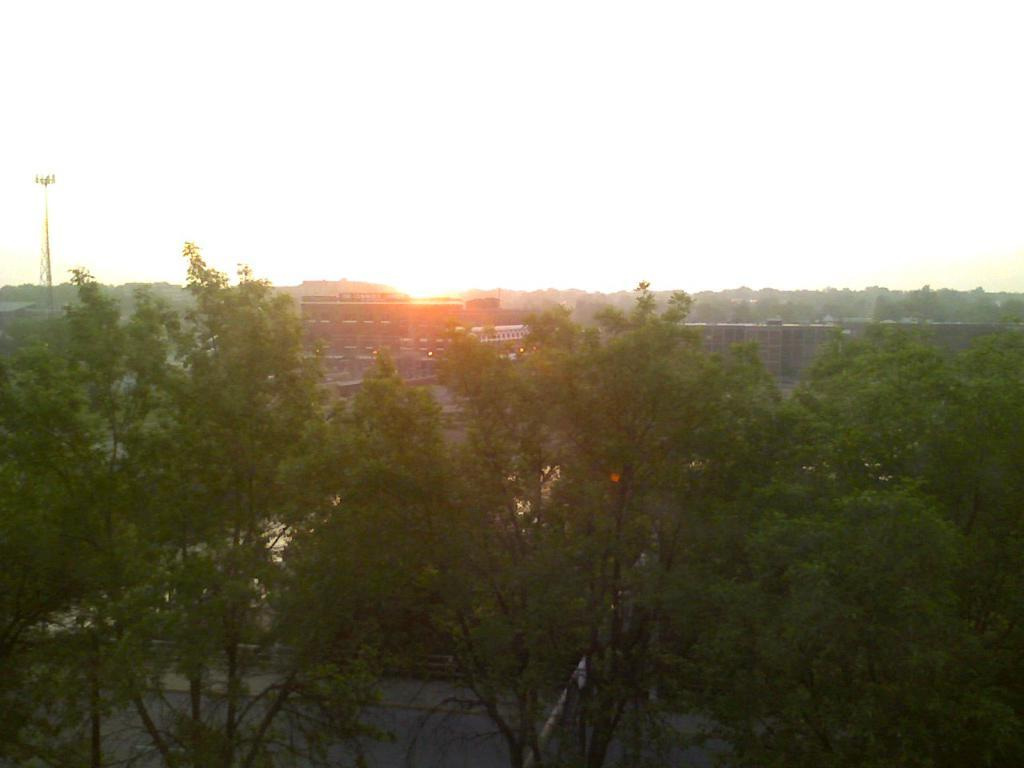What type of vegetation can be seen in the image? There are trees in the image. What is the color of the trees? The trees are green. What structures are visible in the background of the image? There are buildings and a tower in the background of the image. What is the color of the sky in the image? The sky is white in color. What type of pan is being used to show the fan in the image? There is no pan, show, or fan present in the image. 